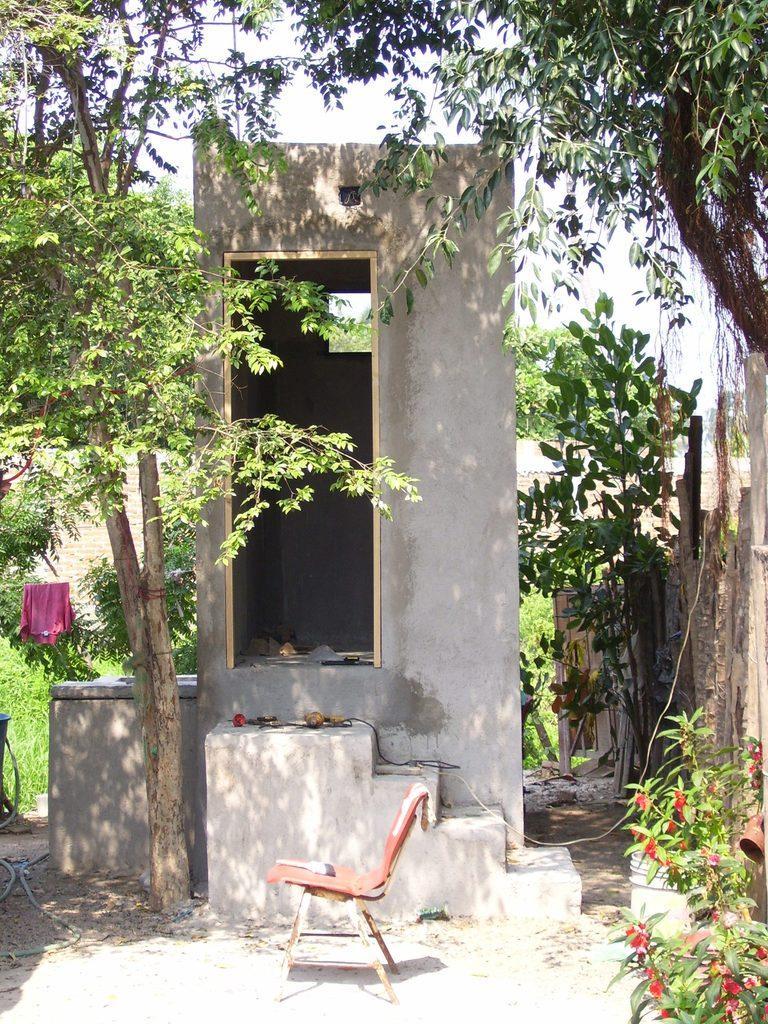Describe this image in one or two sentences. In this image there is a chair, in the background there is a washroom, trees, in the bottom right there is a plant. 